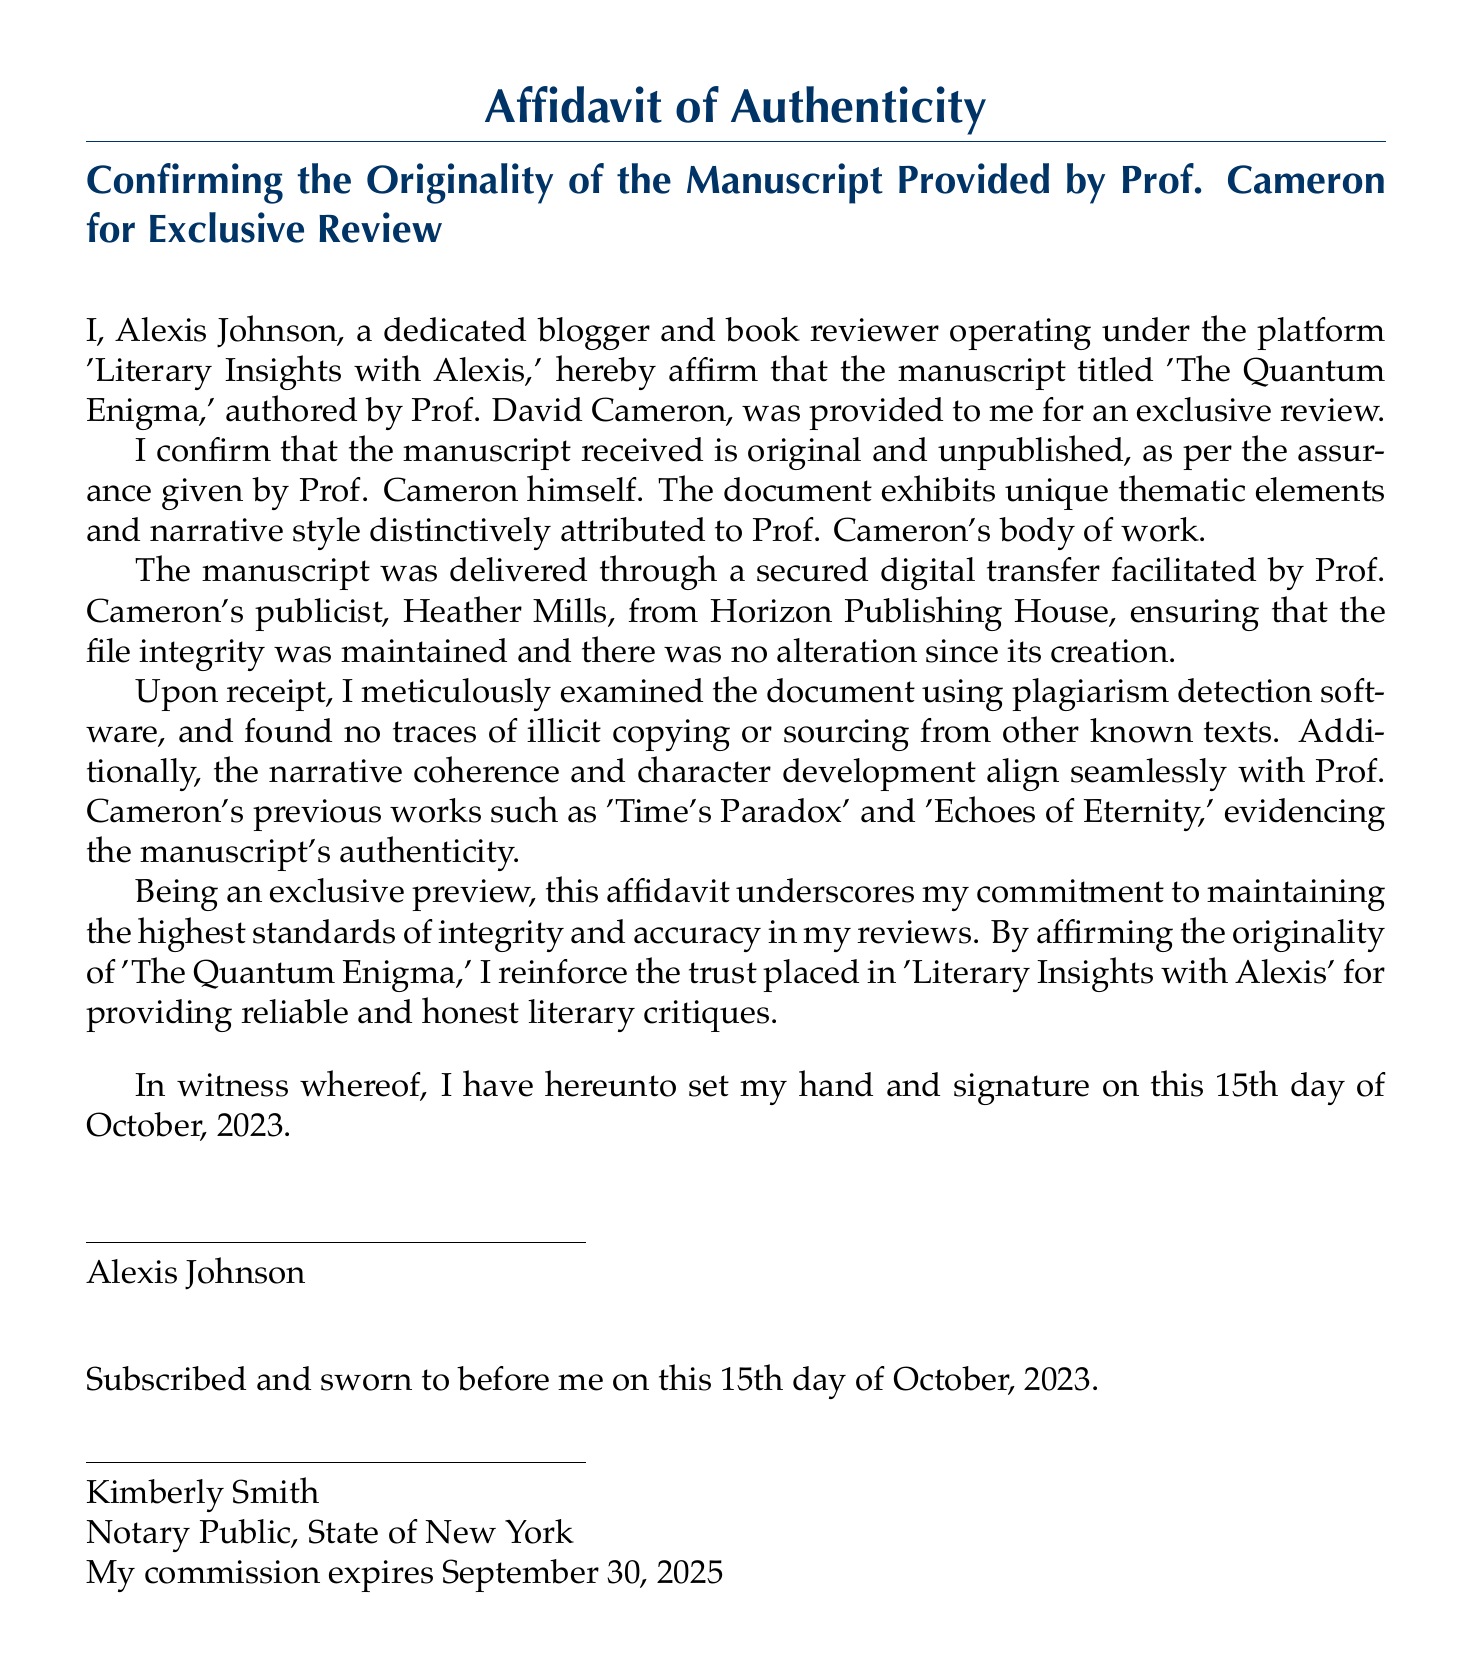What is the title of the manuscript? The title of the manuscript is mentioned prominently at the beginning of the document.
Answer: The Quantum Enigma Who is the author of the manuscript? The author is named within the affidavit as the person who authored the manuscript.
Answer: Prof. David Cameron What is the date the affidavit was signed? The date is clearly stated in the closing section of the document.
Answer: October 15, 2023 Who provided the manuscript? The name of the individual who delivered the manuscript is specified in the document.
Answer: Heather Mills What publication house is associated with the manuscript? The publishing house is mentioned in relation to the manuscript's transfer.
Answer: Horizon Publishing House What software was used to check the manuscript's originality? The affidavit specifies a type of software used for examination.
Answer: Plagiarism detection software What is the platform name of the blogger? The blogger's platform is included in the introductory statement of the affidavit.
Answer: Literary Insights with Alexis Who notarized the affidavit? The name of the notary public is mentioned towards the end of the document.
Answer: Kimberly Smith 